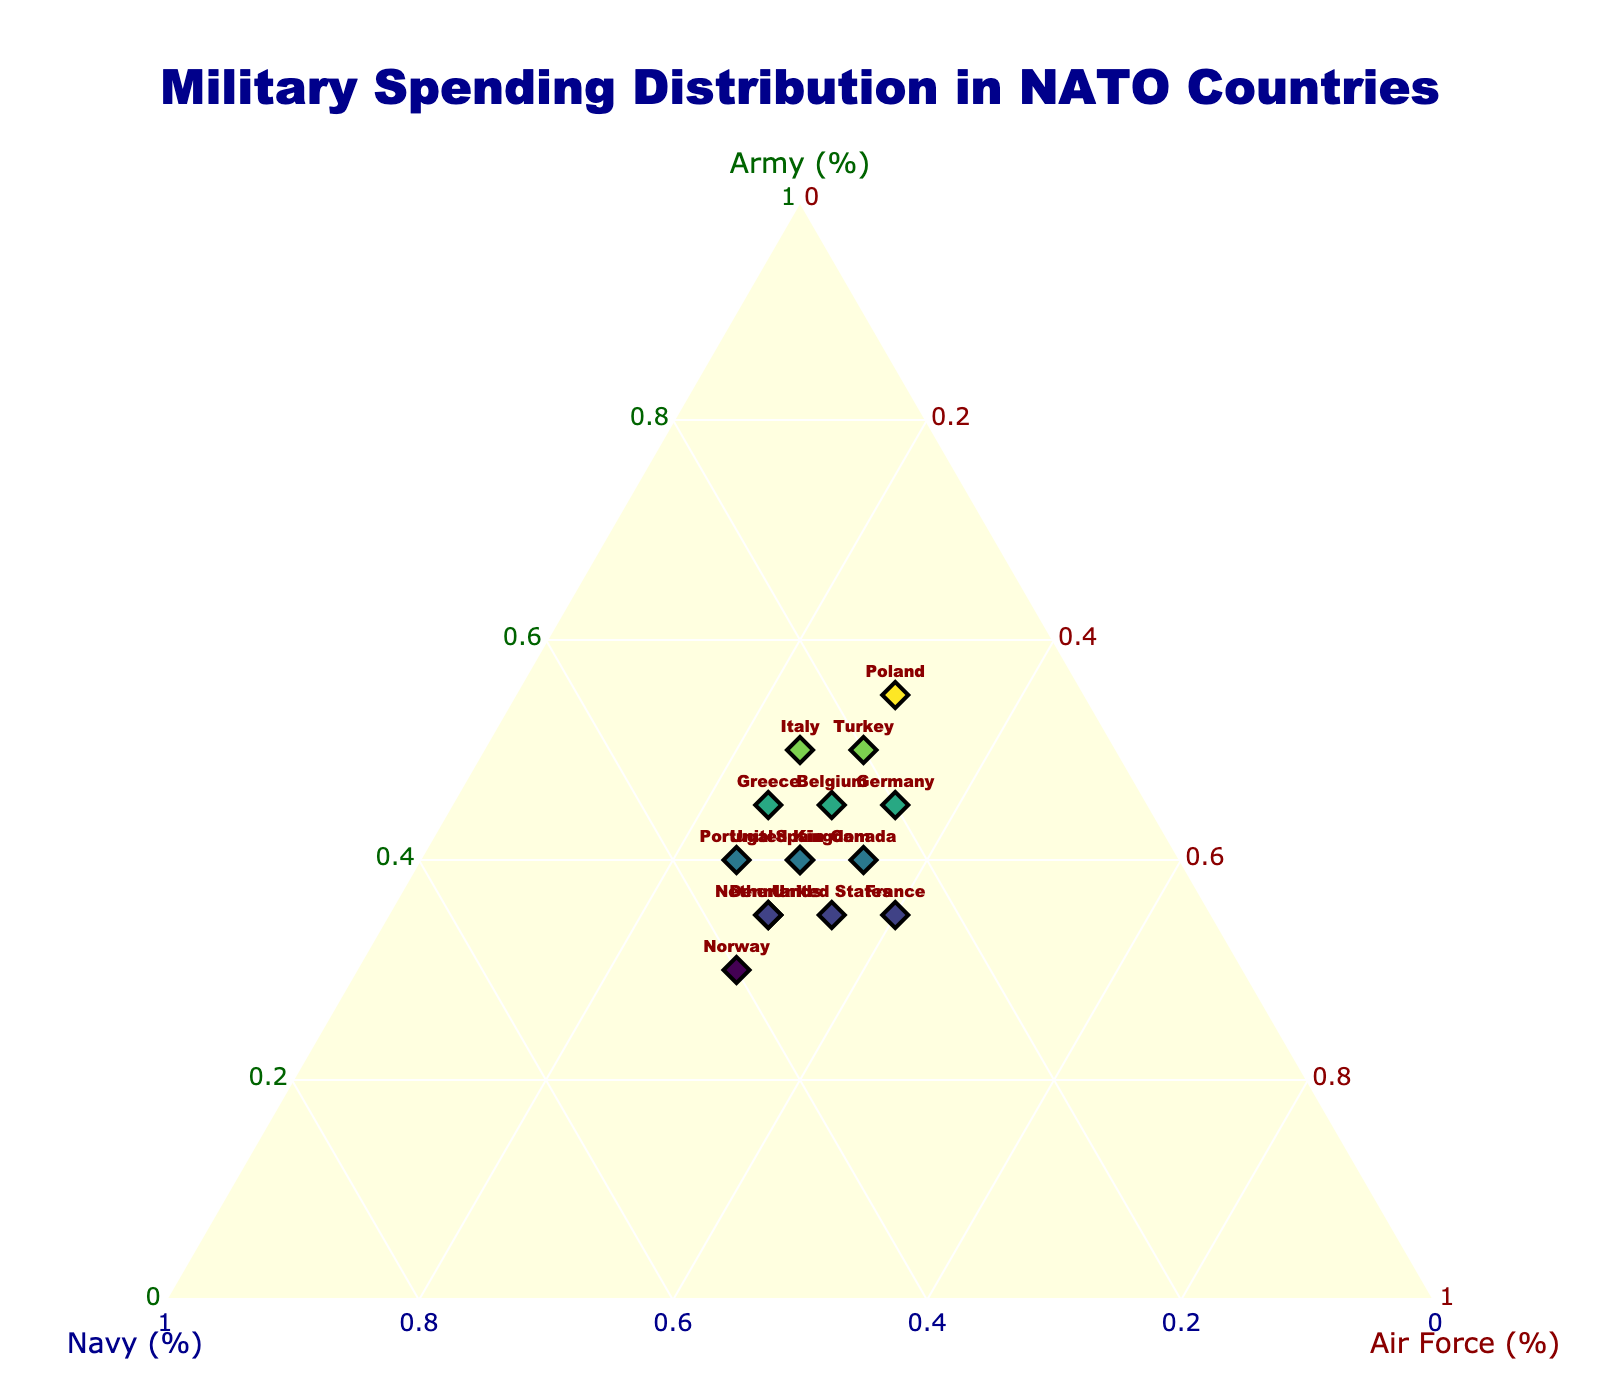What is the title of the plot? The title of the plot is displayed at the top and reads "Military Spending Distribution in NATO Countries". This can be seen in the center of the plot.
Answer: Military Spending Distribution in NATO Countries On the ternary plot, which country allocates the most percentage of its military spending to the Army? By inspecting the markers towards the apex labeled 'Army (%)', the highest percentage for the Army is 55%, which is designated to Poland.
Answer: Poland Which country in the plot has an equal distribution of military spending among the three branches? The country markers with roughly equal distribution of values will be near the center of the ternary plot, at the convergence point where Army, Navy, and Air Force percentages are similar. Spain and the United Kingdom both show equal distribution with percentages being 40-30-30 for Spain and 40-30-30 for the UK.
Answer: Spain and the United Kingdom What is the average percentage of military spending on the Navy for Germany and Turkey? First, locate Germany and Turkey on the plot and find their Navy spending percentages: Germany has 20%, and Turkey has 20%. The average is calculated as (20 + 20) / 2.
Answer: 20% Which country spends more on the Air Force: France or the Netherlands? By locating France and Netherlands on the plot and examining their positions along the 'Air Force (%)' axis, we see France allocates 40%, whereas the Netherlands allocates 30%. Hence, France spends more.
Answer: France Which countries spend 50% of their military budget on the Army? To answer this, identify the markers that are near the 50% mark on the 'Army (%)' axis. Both Italy and Turkey dedicate 50% of their military spending to the Army.
Answer: Italy and Turkey How does military spending on the Navy for Norway compare to Denmark? Norway's position on the 'Navy (%)' axis indicates 40% spending on the Navy, whereas Denmark's position indicates 35%. Norway spends more on the Navy.
Answer: Norway What is the total percentage of military spending allocated to the Air Force by United States and Belgium? First, find the Air Force percentages for the United States (35%) and Belgium (30%). Adding these values gives 35 + 30 = 65.
Answer: 65% Which country has the highest combined spending on the Navy and Air Force? Locate markers and sum the percentages of Navy and Air Force for each country. France spends 25% (Navy) + 40% (Air Force) = 65%, which is the highest observed on the plot.
Answer: France Identify the country that has the closest to an even split of military spending among the three branches. This country will be near the center of the plot. Denmark, with 35-35-30 split, appears closest to an even distribution among the branches.
Answer: Denmark 